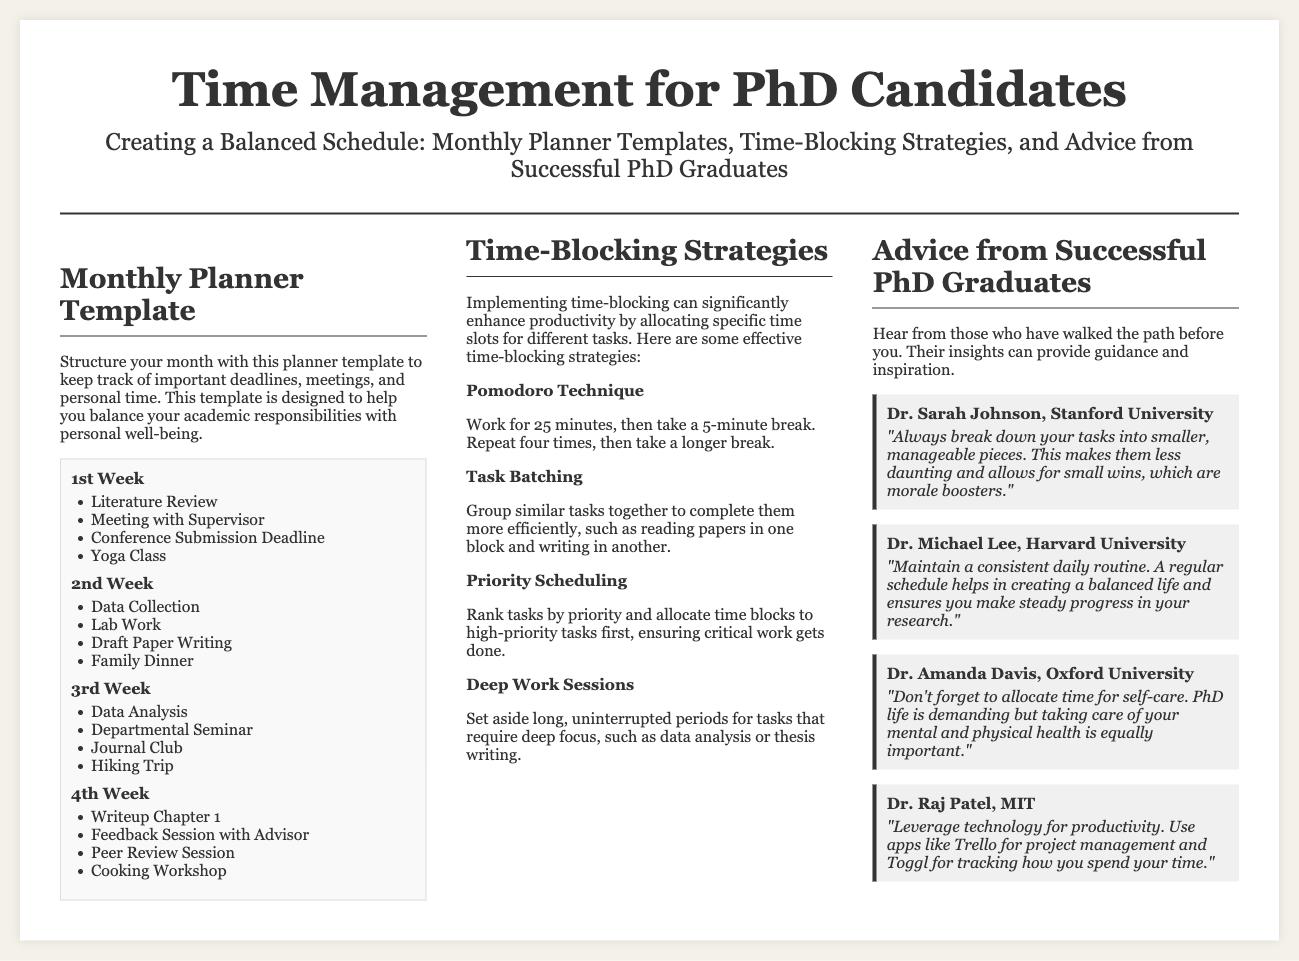What is the main title of the document? The main title is presented at the top of the document, which is focused on time management for PhD candidates.
Answer: Time Management for PhD Candidates How many weeks are included in the monthly planner template? The document outlines a monthly planner template that consists of four weeks.
Answer: Four weeks Name one time-blocking strategy mentioned in the document. The document lists various time-blocking strategies; any of these can be valid as an answer.
Answer: Pomodoro Technique Who is Dr. Sarah Johnson affiliated with? The document includes names and affiliations of successful PhD graduates sharing advice, highlighting her university.
Answer: Stanford University What is the last activity listed in the 4th week of the planner? The document specifies the activities for each week, and the last one for the 4th week can be directly referenced.
Answer: Cooking Workshop Which time-blocking strategy involves working for 25 minutes? The specific time-blocking strategy that includes this duration is described in the document.
Answer: Pomodoro Technique What is one piece of advice given by Dr. Amanda Davis? The document shares advice from successful graduates, which can be directly quoted for this question.
Answer: Allocate time for self-care How many time-blocking strategies are described in the document? The document lists several effective time-blocking strategies altogether.
Answer: Four strategies 